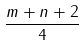<formula> <loc_0><loc_0><loc_500><loc_500>\frac { m + n + 2 } { 4 }</formula> 